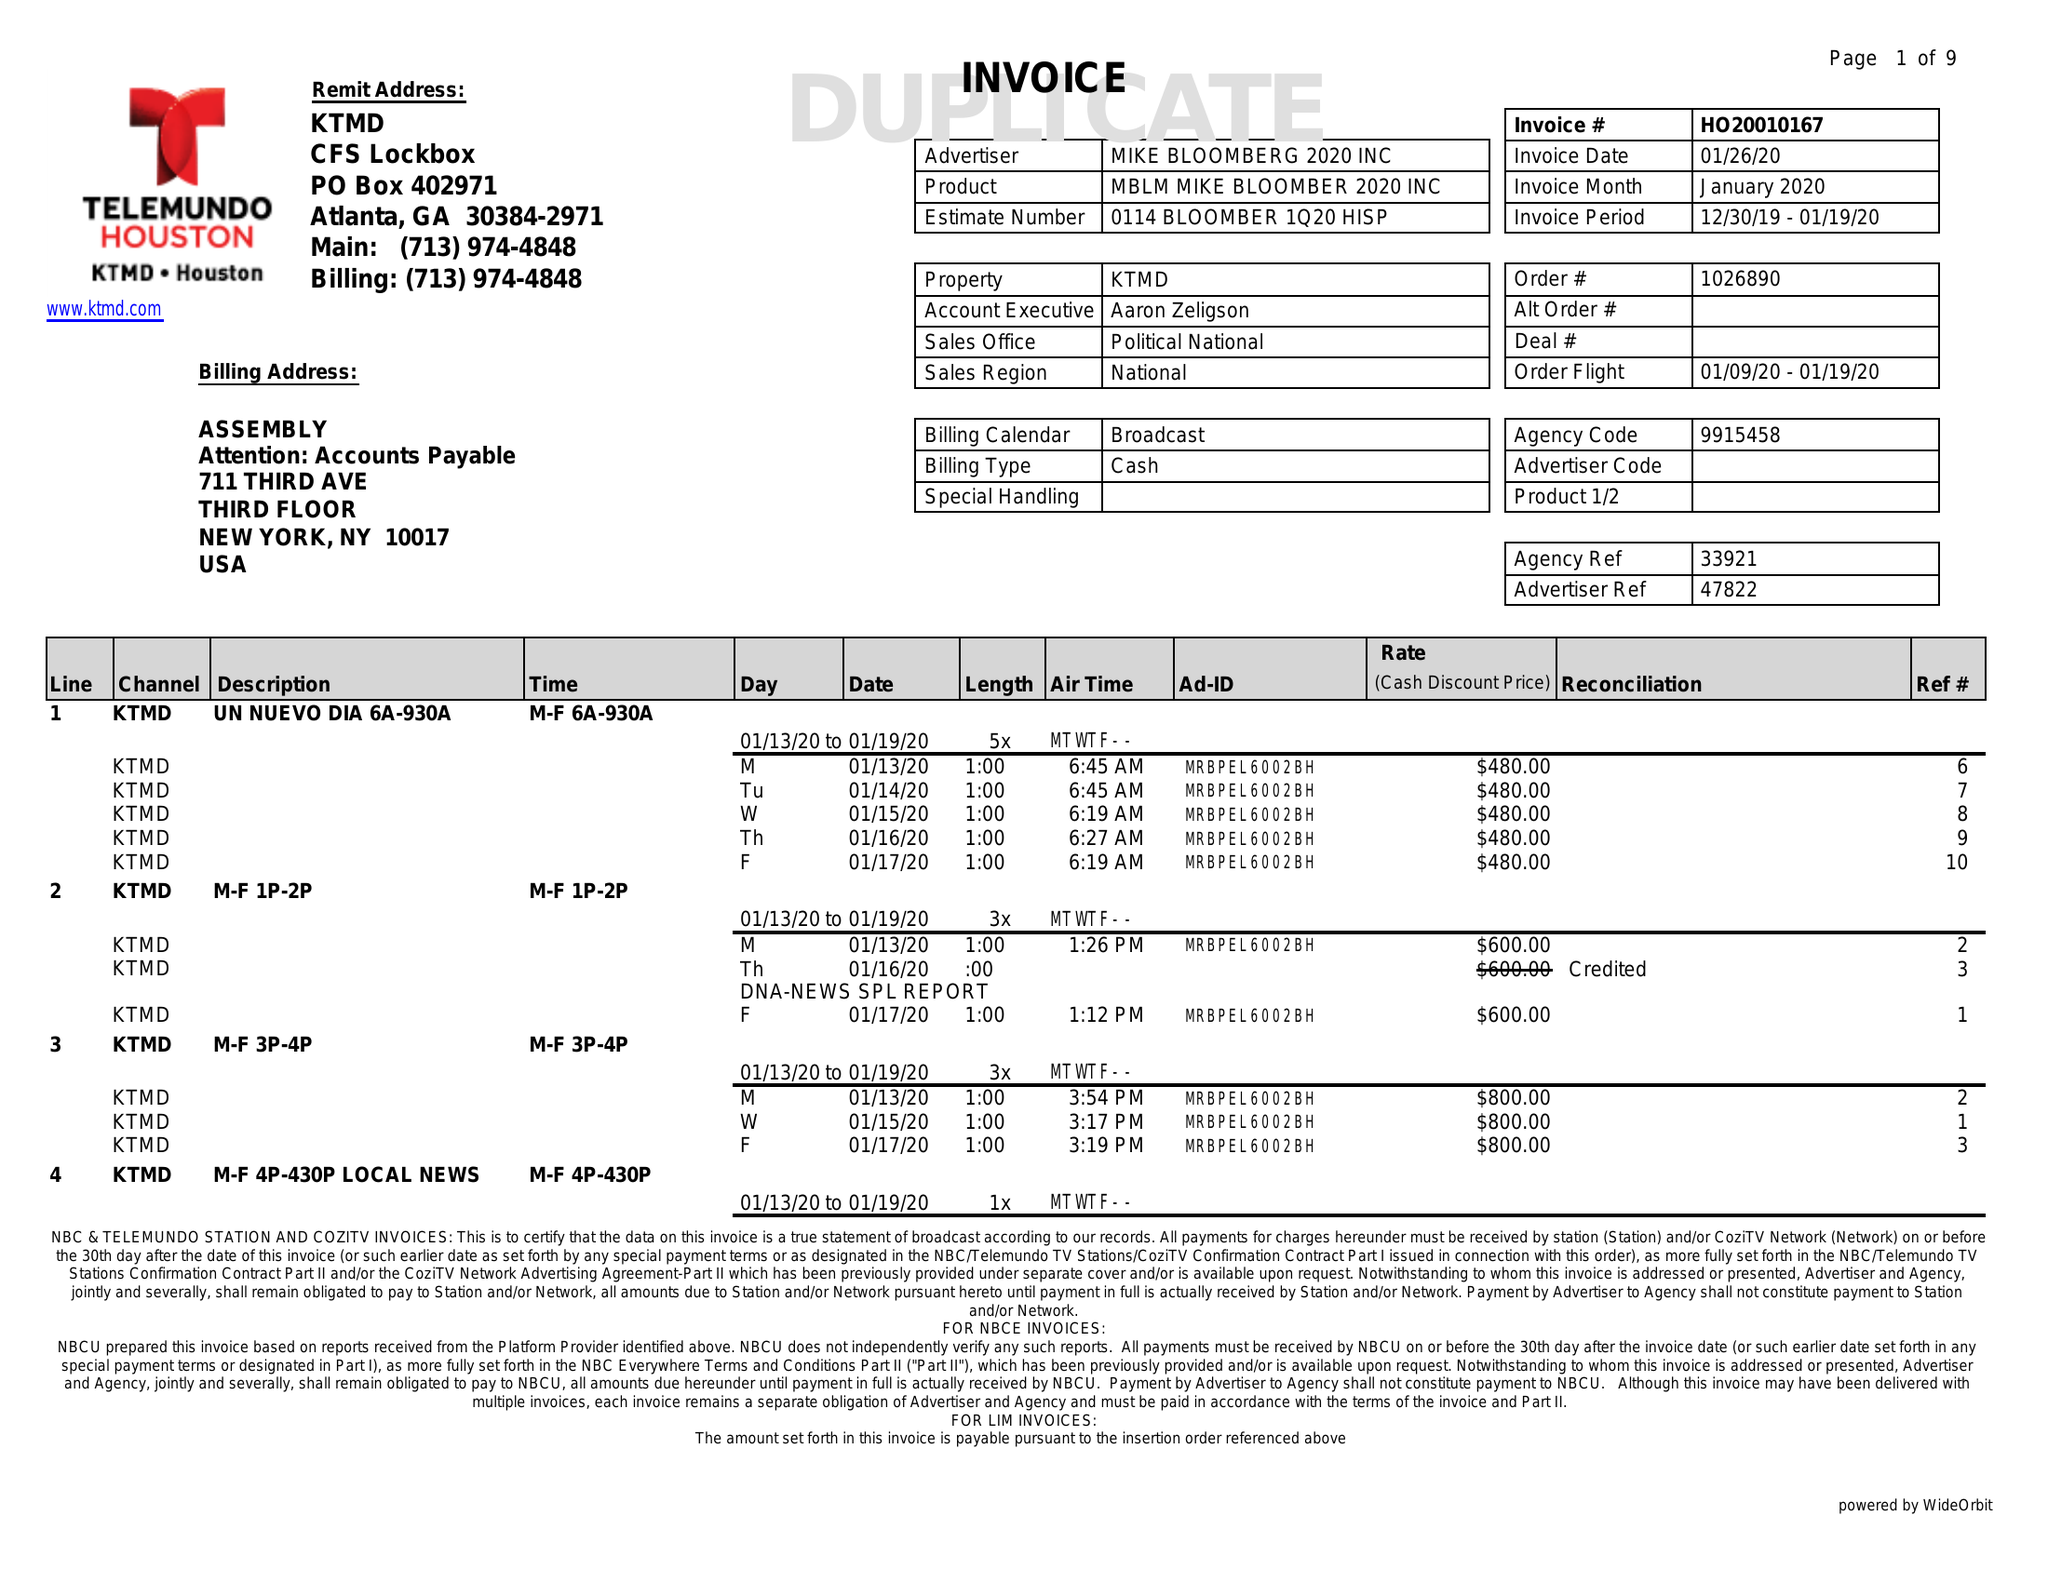What is the value for the gross_amount?
Answer the question using a single word or phrase. 84270.00 